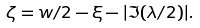Convert formula to latex. <formula><loc_0><loc_0><loc_500><loc_500>\zeta = w / 2 - \xi - | \Im ( \lambda / 2 ) | .</formula> 